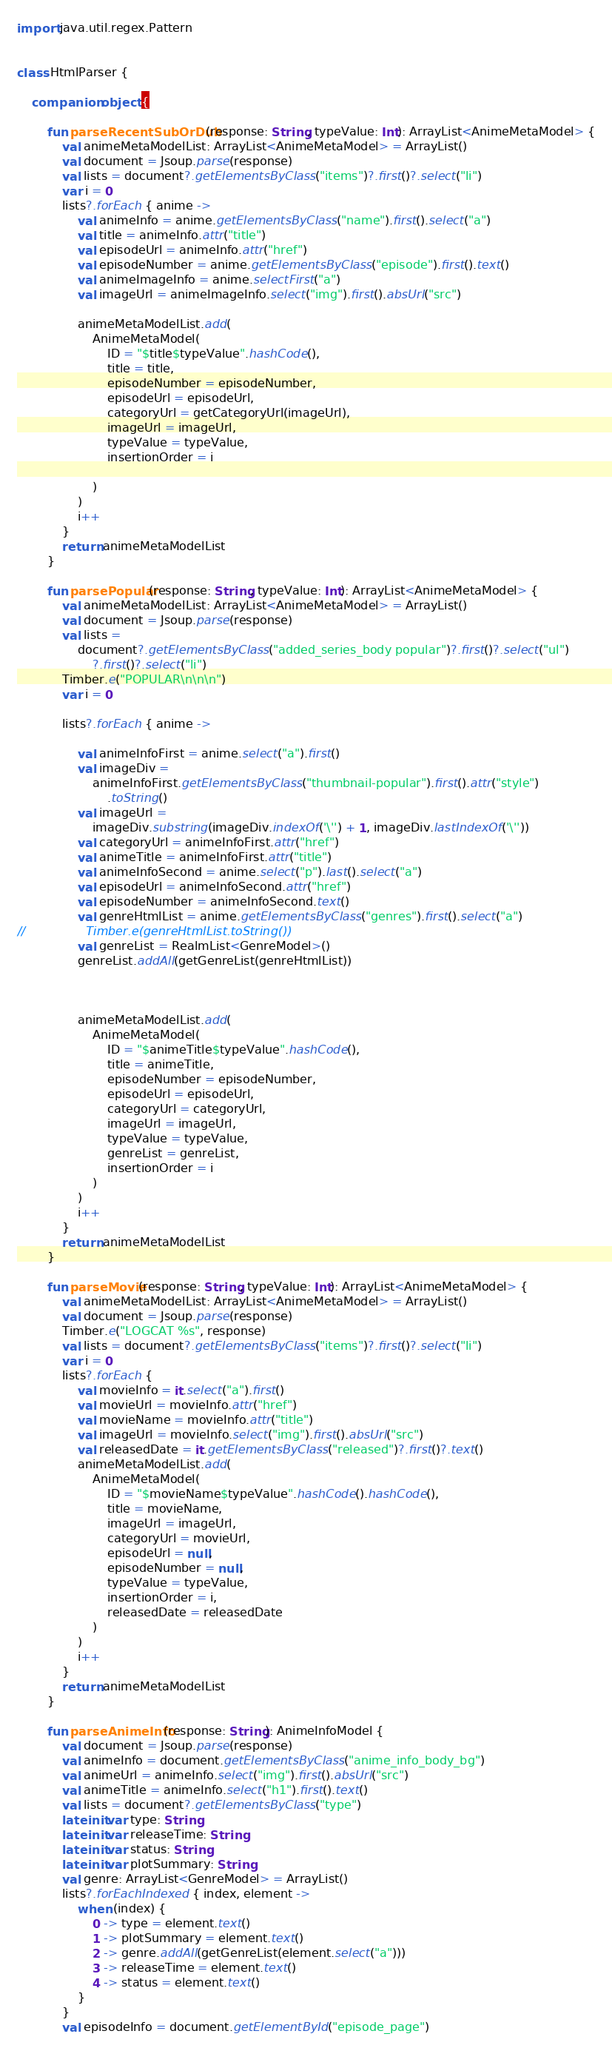Convert code to text. <code><loc_0><loc_0><loc_500><loc_500><_Kotlin_>import java.util.regex.Pattern


class HtmlParser {

    companion object {

        fun parseRecentSubOrDub(response: String, typeValue: Int): ArrayList<AnimeMetaModel> {
            val animeMetaModelList: ArrayList<AnimeMetaModel> = ArrayList()
            val document = Jsoup.parse(response)
            val lists = document?.getElementsByClass("items")?.first()?.select("li")
            var i = 0
            lists?.forEach { anime ->
                val animeInfo = anime.getElementsByClass("name").first().select("a")
                val title = animeInfo.attr("title")
                val episodeUrl = animeInfo.attr("href")
                val episodeNumber = anime.getElementsByClass("episode").first().text()
                val animeImageInfo = anime.selectFirst("a")
                val imageUrl = animeImageInfo.select("img").first().absUrl("src")

                animeMetaModelList.add(
                    AnimeMetaModel(
                        ID = "$title$typeValue".hashCode(),
                        title = title,
                        episodeNumber = episodeNumber,
                        episodeUrl = episodeUrl,
                        categoryUrl = getCategoryUrl(imageUrl),
                        imageUrl = imageUrl,
                        typeValue = typeValue,
                        insertionOrder = i

                    )
                )
                i++
            }
            return animeMetaModelList
        }

        fun parsePopular(response: String, typeValue: Int): ArrayList<AnimeMetaModel> {
            val animeMetaModelList: ArrayList<AnimeMetaModel> = ArrayList()
            val document = Jsoup.parse(response)
            val lists =
                document?.getElementsByClass("added_series_body popular")?.first()?.select("ul")
                    ?.first()?.select("li")
            Timber.e("POPULAR\n\n\n")
            var i = 0

            lists?.forEach { anime ->

                val animeInfoFirst = anime.select("a").first()
                val imageDiv =
                    animeInfoFirst.getElementsByClass("thumbnail-popular").first().attr("style")
                        .toString()
                val imageUrl =
                    imageDiv.substring(imageDiv.indexOf('\'') + 1, imageDiv.lastIndexOf('\''))
                val categoryUrl = animeInfoFirst.attr("href")
                val animeTitle = animeInfoFirst.attr("title")
                val animeInfoSecond = anime.select("p").last().select("a")
                val episodeUrl = animeInfoSecond.attr("href")
                val episodeNumber = animeInfoSecond.text()
                val genreHtmlList = anime.getElementsByClass("genres").first().select("a")
//                Timber.e(genreHtmlList.toString())
                val genreList = RealmList<GenreModel>()
                genreList.addAll(getGenreList(genreHtmlList))



                animeMetaModelList.add(
                    AnimeMetaModel(
                        ID = "$animeTitle$typeValue".hashCode(),
                        title = animeTitle,
                        episodeNumber = episodeNumber,
                        episodeUrl = episodeUrl,
                        categoryUrl = categoryUrl,
                        imageUrl = imageUrl,
                        typeValue = typeValue,
                        genreList = genreList,
                        insertionOrder = i
                    )
                )
                i++
            }
            return animeMetaModelList
        }

        fun parseMovie(response: String, typeValue: Int): ArrayList<AnimeMetaModel> {
            val animeMetaModelList: ArrayList<AnimeMetaModel> = ArrayList()
            val document = Jsoup.parse(response)
            Timber.e("LOGCAT %s", response)
            val lists = document?.getElementsByClass("items")?.first()?.select("li")
            var i = 0
            lists?.forEach {
                val movieInfo = it.select("a").first()
                val movieUrl = movieInfo.attr("href")
                val movieName = movieInfo.attr("title")
                val imageUrl = movieInfo.select("img").first().absUrl("src")
                val releasedDate = it.getElementsByClass("released")?.first()?.text()
                animeMetaModelList.add(
                    AnimeMetaModel(
                        ID = "$movieName$typeValue".hashCode().hashCode(),
                        title = movieName,
                        imageUrl = imageUrl,
                        categoryUrl = movieUrl,
                        episodeUrl = null,
                        episodeNumber = null,
                        typeValue = typeValue,
                        insertionOrder = i,
                        releasedDate = releasedDate
                    )
                )
                i++
            }
            return animeMetaModelList
        }

        fun parseAnimeInfo(response: String): AnimeInfoModel {
            val document = Jsoup.parse(response)
            val animeInfo = document.getElementsByClass("anime_info_body_bg")
            val animeUrl = animeInfo.select("img").first().absUrl("src")
            val animeTitle = animeInfo.select("h1").first().text()
            val lists = document?.getElementsByClass("type")
            lateinit var type: String
            lateinit var releaseTime: String
            lateinit var status: String
            lateinit var plotSummary: String
            val genre: ArrayList<GenreModel> = ArrayList()
            lists?.forEachIndexed { index, element ->
                when (index) {
                    0 -> type = element.text()
                    1 -> plotSummary = element.text()
                    2 -> genre.addAll(getGenreList(element.select("a")))
                    3 -> releaseTime = element.text()
                    4 -> status = element.text()
                }
            }
            val episodeInfo = document.getElementById("episode_page")</code> 